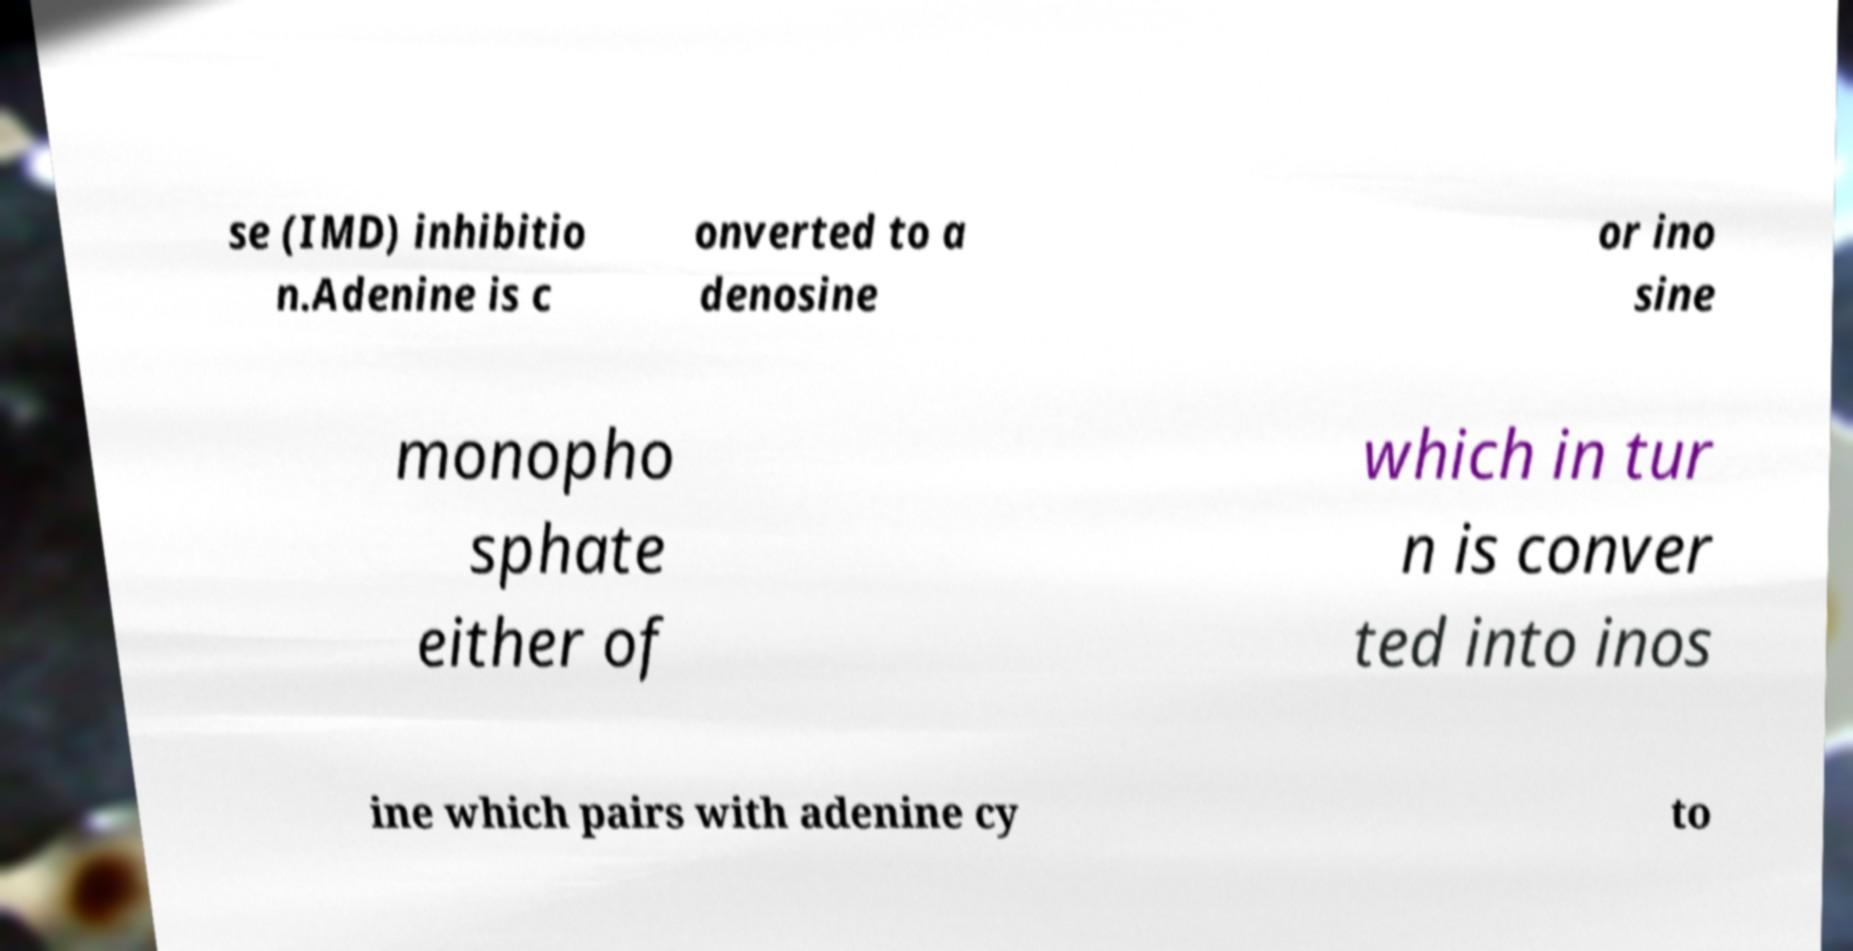Could you assist in decoding the text presented in this image and type it out clearly? se (IMD) inhibitio n.Adenine is c onverted to a denosine or ino sine monopho sphate either of which in tur n is conver ted into inos ine which pairs with adenine cy to 